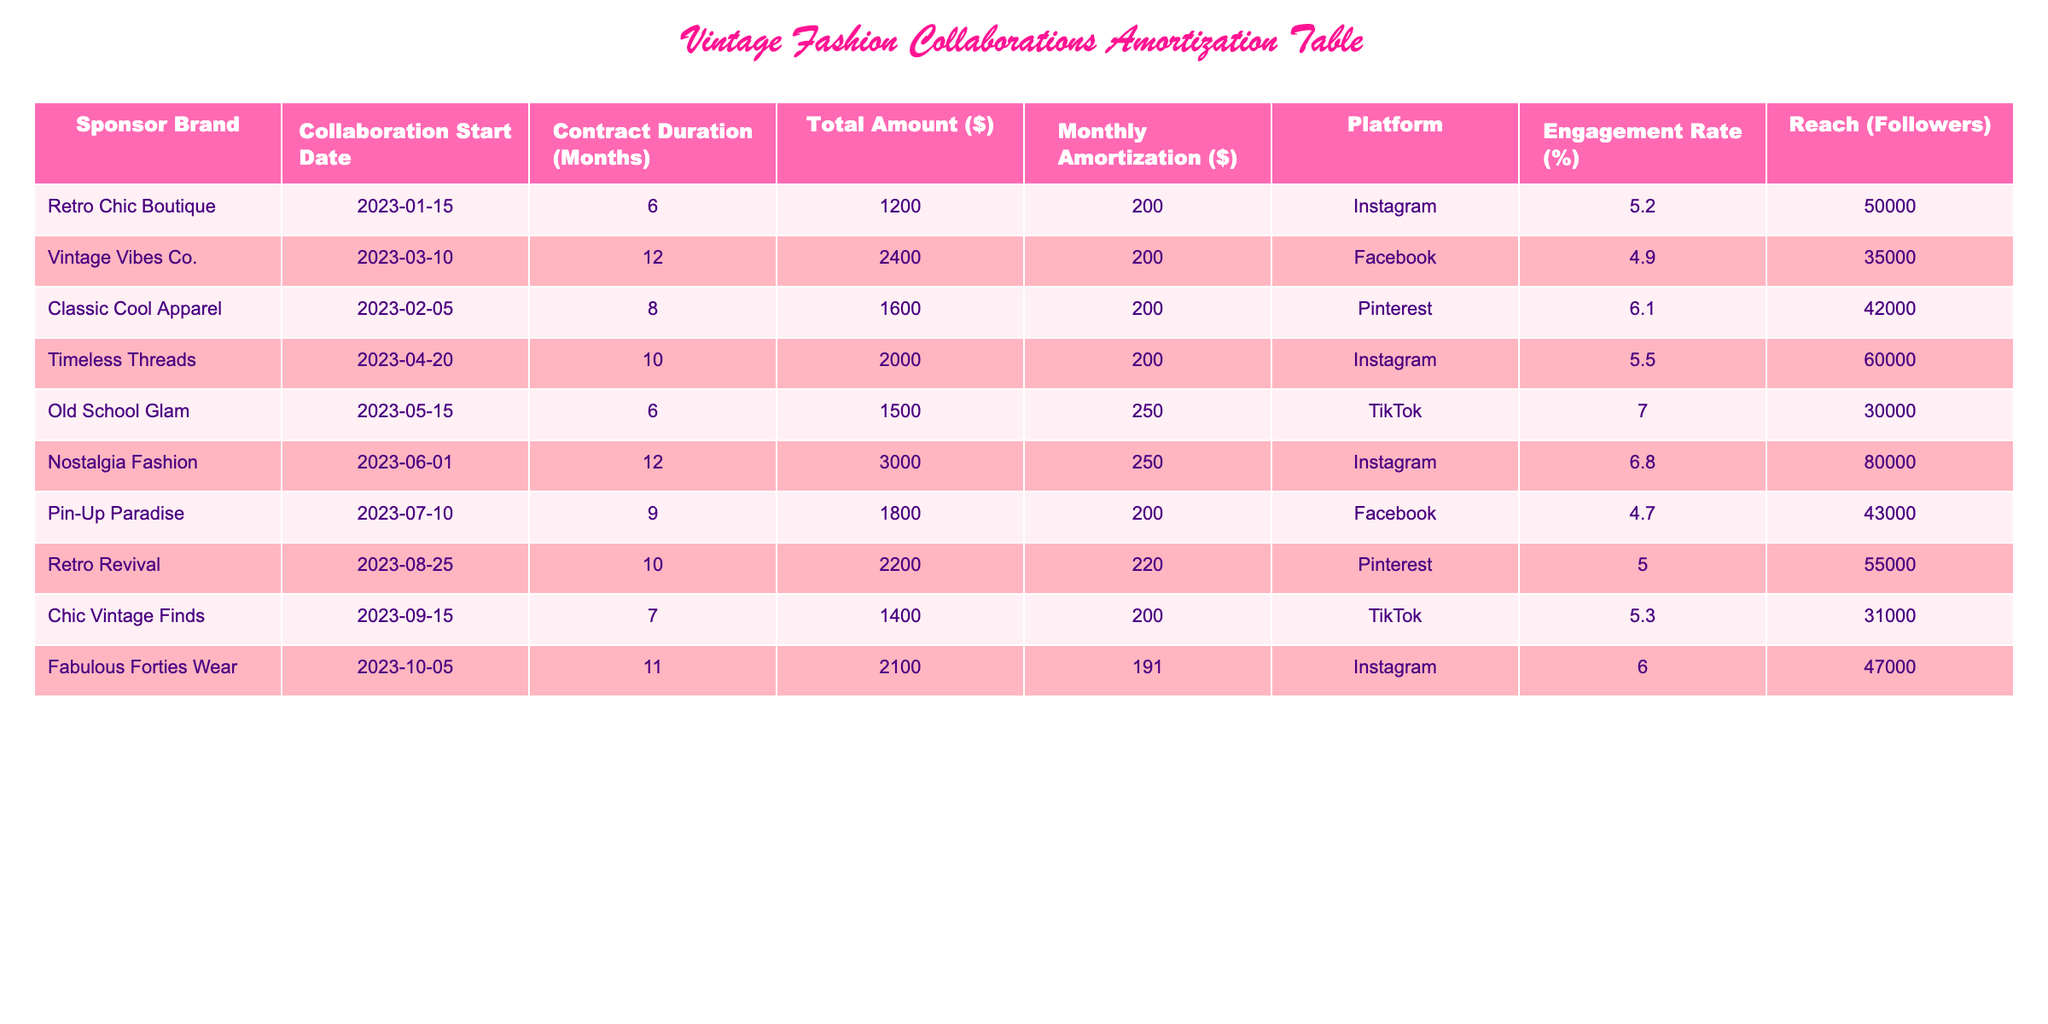What is the total amount for the collaboration with Nostalgia Fashion? The table shows that the total amount for the collaboration with Nostalgia Fashion is $3000.
Answer: 3000 Which platform has the highest engagement rate based on the data? By inspecting the engagement rates in the table, Old School Glam has the highest engagement rate at 7.0%.
Answer: 7.0% What is the average monthly amortization for all collaborations listed? The monthly amortization values are 200, 200, 200, 200, 250, 250, 200, 220, 200, and 191. Summing these gives 2,013, and dividing by the number of collaborations (10) yields an average of 201.3.
Answer: 201.3 Is the collaboration with Fabulous Forties Wear more than 10 months in duration? The duration for Fabulous Forties Wear is 11 months, which is greater than 10 months, so the answer is yes.
Answer: Yes Which collaboration provides the most reach, and what is the reach value? Nostalgia Fashion has the largest reach at 80,000 followers according to the reach column in the table.
Answer: 80000 What is the difference in total amounts between the highest and lowest collaborations? The highest total is $3000 (Nostalgia Fashion) and the lowest is $1200 (Retro Chic Boutique). The difference is $3000 - $1200 = $1800.
Answer: 1800 How many collaborations have a contract duration of less than 8 months? In the table, Retro Chic Boutique, Old School Glam, and Chic Vintage Finds all have durations of 6 or 7 months. Therefore, there are 3 total collaborations with durations less than 8 months.
Answer: 3 Is the engagement rate for Chic Vintage Finds less than 5%? The engagement rate for Chic Vintage Finds is 5.3%, which is not less than 5%. Therefore, the answer is no.
Answer: No How much is the total monthly amortization for all collaborations on Instagram? There are four collaborations on Instagram: Retro Chic Boutique, Timeless Threads, Nostalgia Fashion, and Fabulous Forties Wear. Their monthly amortization values are 200, 200, 250, and 191 respectively. Adding these gives 200 + 200 + 250 + 191 = 841.
Answer: 841 